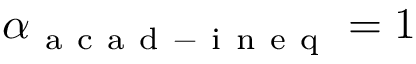Convert formula to latex. <formula><loc_0><loc_0><loc_500><loc_500>\alpha _ { a c a d - i n e q } = 1</formula> 